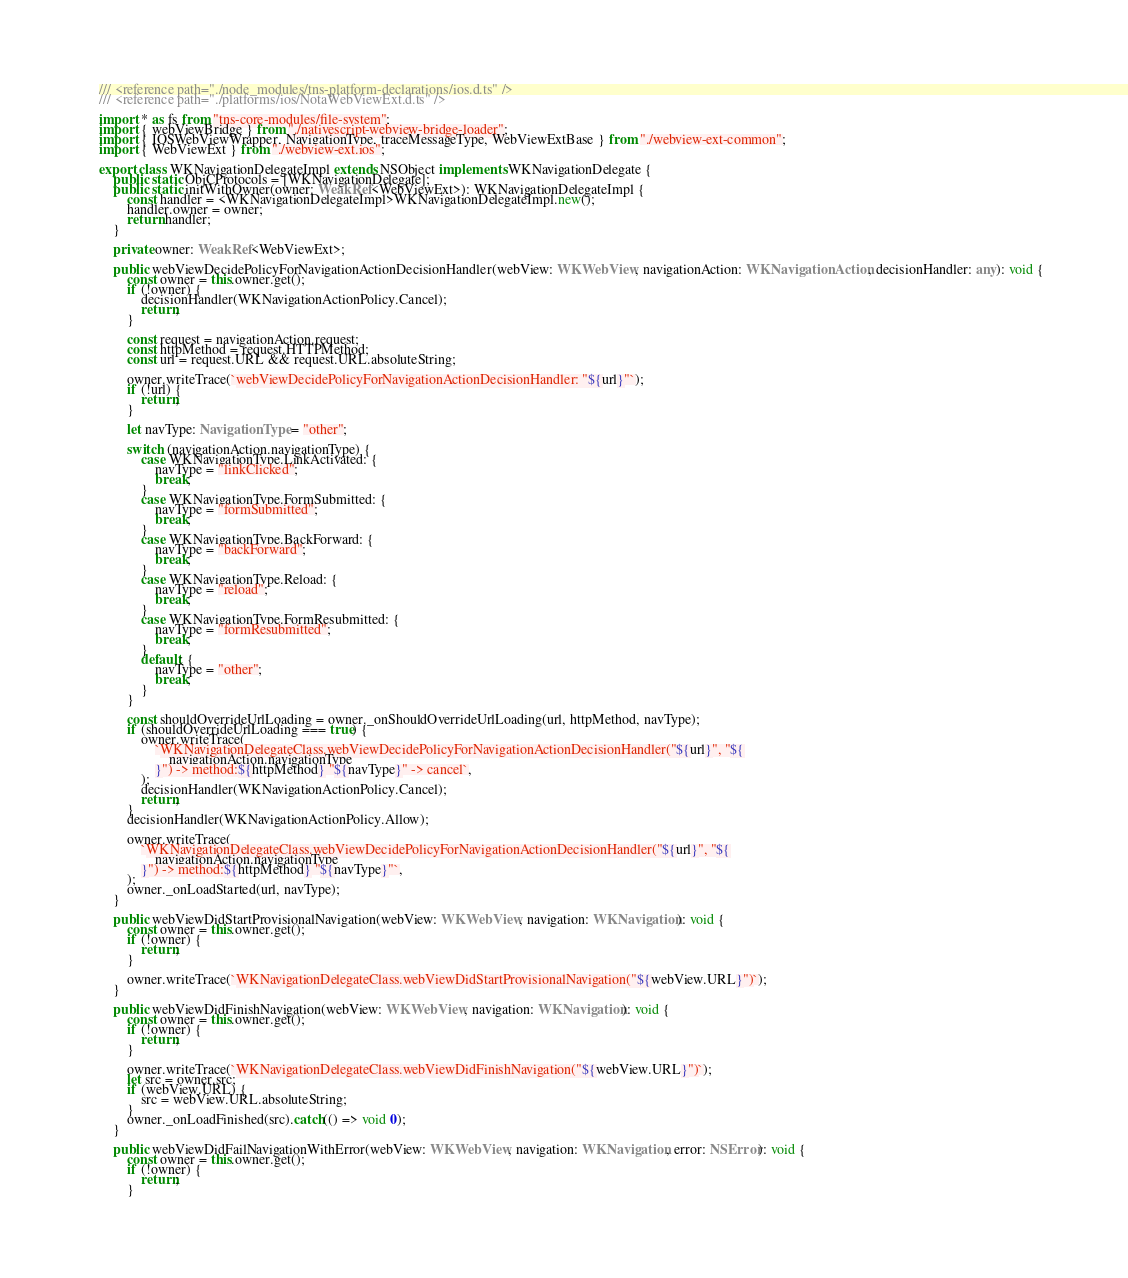<code> <loc_0><loc_0><loc_500><loc_500><_TypeScript_>/// <reference path="./node_modules/tns-platform-declarations/ios.d.ts" />
/// <reference path="./platforms/ios/NotaWebViewExt.d.ts" />

import * as fs from "tns-core-modules/file-system";
import { webViewBridge } from "./nativescript-webview-bridge-loader";
import { IOSWebViewWrapper, NavigationType, traceMessageType, WebViewExtBase } from "./webview-ext-common";
import { WebViewExt } from "./webview-ext.ios";

export class WKNavigationDelegateImpl extends NSObject implements WKNavigationDelegate {
    public static ObjCProtocols = [WKNavigationDelegate];
    public static initWithOwner(owner: WeakRef<WebViewExt>): WKNavigationDelegateImpl {
        const handler = <WKNavigationDelegateImpl>WKNavigationDelegateImpl.new();
        handler.owner = owner;
        return handler;
    }

    private owner: WeakRef<WebViewExt>;

    public webViewDecidePolicyForNavigationActionDecisionHandler(webView: WKWebView, navigationAction: WKNavigationAction, decisionHandler: any): void {
        const owner = this.owner.get();
        if (!owner) {
            decisionHandler(WKNavigationActionPolicy.Cancel);
            return;
        }

        const request = navigationAction.request;
        const httpMethod = request.HTTPMethod;
        const url = request.URL && request.URL.absoluteString;

        owner.writeTrace(`webViewDecidePolicyForNavigationActionDecisionHandler: "${url}"`);
        if (!url) {
            return;
        }

        let navType: NavigationType = "other";

        switch (navigationAction.navigationType) {
            case WKNavigationType.LinkActivated: {
                navType = "linkClicked";
                break;
            }
            case WKNavigationType.FormSubmitted: {
                navType = "formSubmitted";
                break;
            }
            case WKNavigationType.BackForward: {
                navType = "backForward";
                break;
            }
            case WKNavigationType.Reload: {
                navType = "reload";
                break;
            }
            case WKNavigationType.FormResubmitted: {
                navType = "formResubmitted";
                break;
            }
            default: {
                navType = "other";
                break;
            }
        }

        const shouldOverrideUrlLoading = owner._onShouldOverrideUrlLoading(url, httpMethod, navType);
        if (shouldOverrideUrlLoading === true) {
            owner.writeTrace(
                `WKNavigationDelegateClass.webViewDecidePolicyForNavigationActionDecisionHandler("${url}", "${
                    navigationAction.navigationType
                }") -> method:${httpMethod} "${navType}" -> cancel`,
            );
            decisionHandler(WKNavigationActionPolicy.Cancel);
            return;
        }
        decisionHandler(WKNavigationActionPolicy.Allow);

        owner.writeTrace(
            `WKNavigationDelegateClass.webViewDecidePolicyForNavigationActionDecisionHandler("${url}", "${
                navigationAction.navigationType
            }") -> method:${httpMethod} "${navType}"`,
        );
        owner._onLoadStarted(url, navType);
    }

    public webViewDidStartProvisionalNavigation(webView: WKWebView, navigation: WKNavigation): void {
        const owner = this.owner.get();
        if (!owner) {
            return;
        }

        owner.writeTrace(`WKNavigationDelegateClass.webViewDidStartProvisionalNavigation("${webView.URL}")`);
    }

    public webViewDidFinishNavigation(webView: WKWebView, navigation: WKNavigation): void {
        const owner = this.owner.get();
        if (!owner) {
            return;
        }

        owner.writeTrace(`WKNavigationDelegateClass.webViewDidFinishNavigation("${webView.URL}")`);
        let src = owner.src;
        if (webView.URL) {
            src = webView.URL.absoluteString;
        }
        owner._onLoadFinished(src).catch(() => void 0);
    }

    public webViewDidFailNavigationWithError(webView: WKWebView, navigation: WKNavigation, error: NSError): void {
        const owner = this.owner.get();
        if (!owner) {
            return;
        }
</code> 